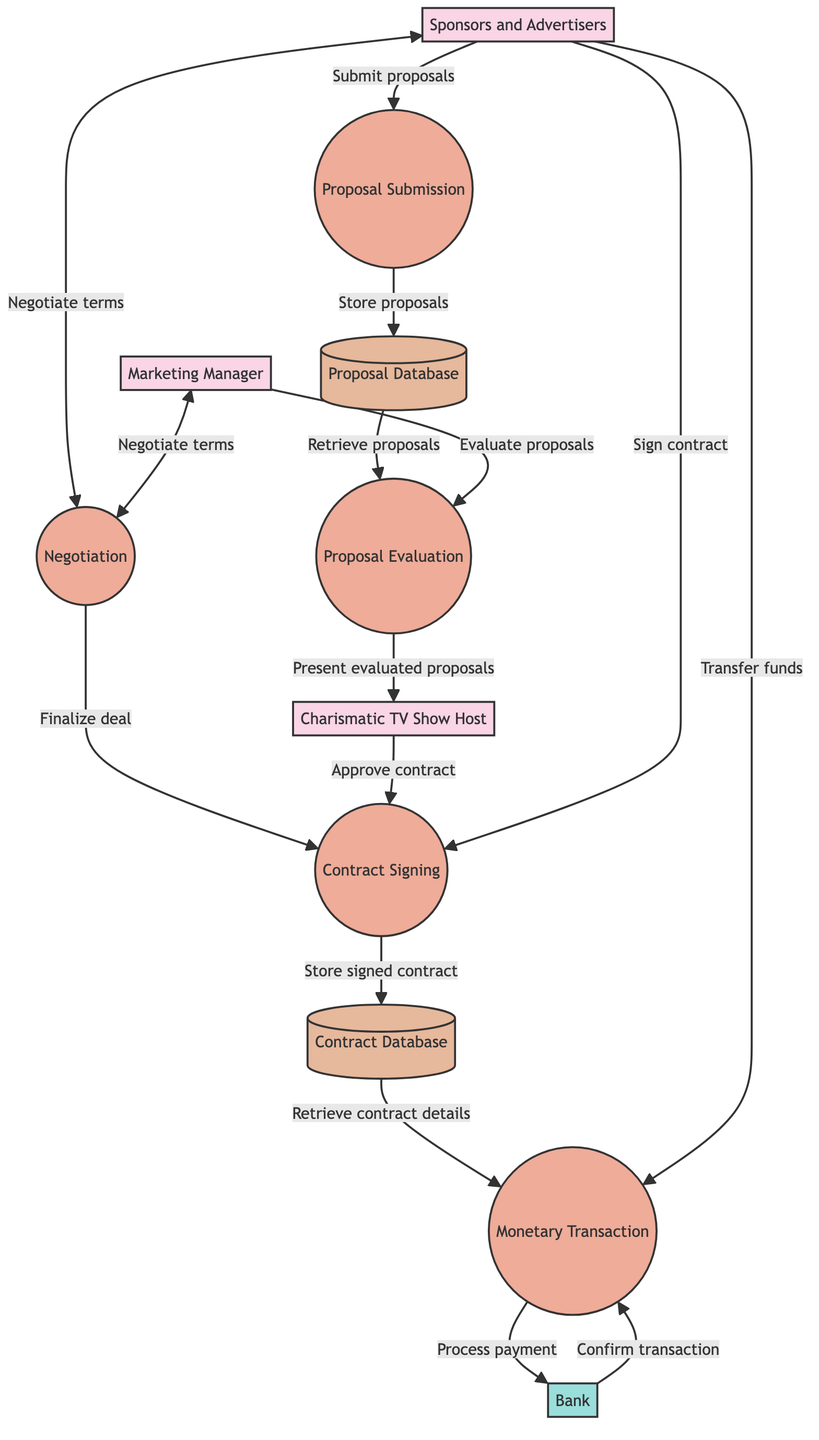What's the first process in the diagram? The first process depicted in the diagram is "Proposal Submission," which initiates the flow of proposals from sponsors and advertisers to the Marketing Manager.
Answer: Proposal Submission How many entities are in the diagram? The diagram lists three entities: the Charismatic TV Show Host, the Marketing Manager, and Sponsors and Advertisers.
Answer: Three What is the final output of the Monetary Transaction process? The Monetary Transaction process outputs to "TV Show Accounting," indicating that the finalized monetary transaction is recorded there.
Answer: TV Show Accounting What role does the Marketing Manager play in the proposal evaluation? The Marketing Manager evaluates the proposals presented to them after they are submitted, which is a key part of the Proposal Evaluation process.
Answer: Evaluate proposals What is stored in the Contract Database? The Contract Database stores signed contracts that have been finalized and approved through the Contract Signing process before monetary transactions occur.
Answer: Signed contracts Which process involves both the Marketing Manager and Sponsors and Advertisers? The Negotiation process involves both the Marketing Manager and Sponsors and Advertisers, where terms are discussed and finalized for a deal.
Answer: Negotiation How is the flow of funds facilitated in the diagram? The flow of funds is facilitated through the Monetary Transaction process, which involves transferring funds from sponsors and advertisers to the TV show, monitored by the Bank.
Answer: Through Monetary Transaction What happens after a signed contract is stored in the Contract Database? Once a signed contract is stored in the Contract Database, it retrieves contract details for processing the Monetary Transaction, marking the next step in the flow.
Answer: Retrieve contract details In terms of data flow, which input leads to the Proposal Evaluation process? The input that leads to the Proposal Evaluation process is the stored proposals from the Proposal Database, which the Marketing Manager accesses for evaluation.
Answer: Proposal Database 